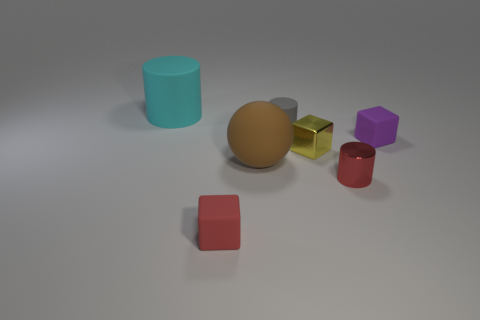Are there any other things that have the same shape as the big brown matte object?
Offer a terse response. No. There is another tiny thing that is the same shape as the red shiny thing; what material is it?
Your answer should be very brief. Rubber. What number of other objects are the same size as the metal cylinder?
Keep it short and to the point. 4. There is a matte cube that is the same color as the small metallic cylinder; what size is it?
Offer a very short reply. Small. How many small rubber cylinders are the same color as the large rubber sphere?
Ensure brevity in your answer.  0. What is the shape of the gray rubber object?
Your answer should be very brief. Cylinder. What is the color of the cylinder that is both to the left of the tiny metallic block and in front of the big cyan object?
Ensure brevity in your answer.  Gray. What is the material of the yellow object?
Keep it short and to the point. Metal. What shape is the tiny red object left of the red cylinder?
Offer a terse response. Cube. There is another matte thing that is the same size as the cyan thing; what color is it?
Your answer should be very brief. Brown. 